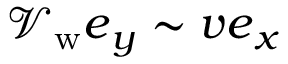Convert formula to latex. <formula><loc_0><loc_0><loc_500><loc_500>\mathcal { V } _ { w } e _ { y } \sim v e _ { x }</formula> 